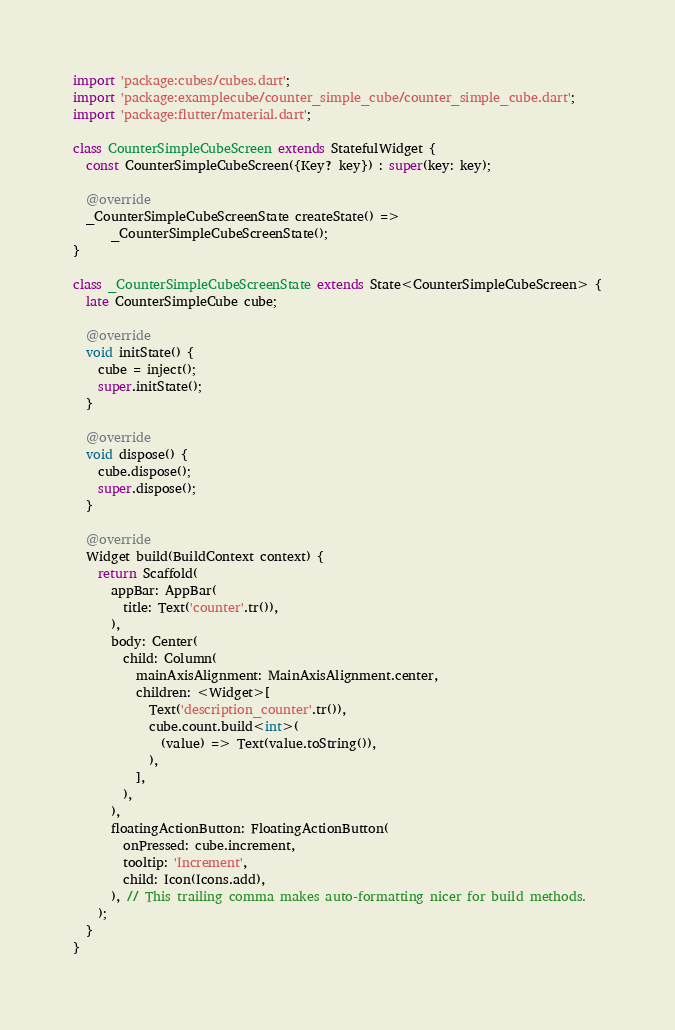<code> <loc_0><loc_0><loc_500><loc_500><_Dart_>import 'package:cubes/cubes.dart';
import 'package:examplecube/counter_simple_cube/counter_simple_cube.dart';
import 'package:flutter/material.dart';

class CounterSimpleCubeScreen extends StatefulWidget {
  const CounterSimpleCubeScreen({Key? key}) : super(key: key);

  @override
  _CounterSimpleCubeScreenState createState() =>
      _CounterSimpleCubeScreenState();
}

class _CounterSimpleCubeScreenState extends State<CounterSimpleCubeScreen> {
  late CounterSimpleCube cube;

  @override
  void initState() {
    cube = inject();
    super.initState();
  }

  @override
  void dispose() {
    cube.dispose();
    super.dispose();
  }

  @override
  Widget build(BuildContext context) {
    return Scaffold(
      appBar: AppBar(
        title: Text('counter'.tr()),
      ),
      body: Center(
        child: Column(
          mainAxisAlignment: MainAxisAlignment.center,
          children: <Widget>[
            Text('description_counter'.tr()),
            cube.count.build<int>(
              (value) => Text(value.toString()),
            ),
          ],
        ),
      ),
      floatingActionButton: FloatingActionButton(
        onPressed: cube.increment,
        tooltip: 'Increment',
        child: Icon(Icons.add),
      ), // This trailing comma makes auto-formatting nicer for build methods.
    );
  }
}
</code> 